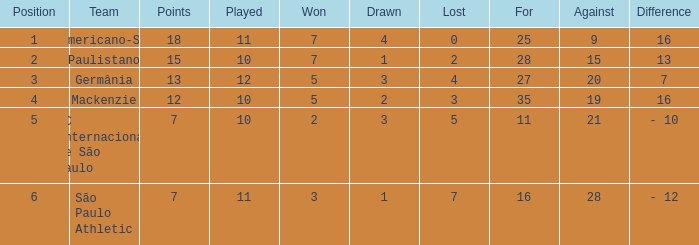Name the most for when difference is 7 27.0. 